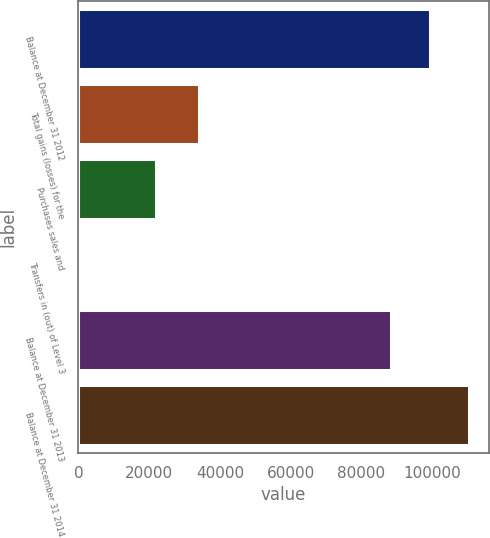<chart> <loc_0><loc_0><loc_500><loc_500><bar_chart><fcel>Balance at December 31 2012<fcel>Total gains (losses) for the<fcel>Purchases sales and<fcel>Transfers in (out) of Level 3<fcel>Balance at December 31 2013<fcel>Balance at December 31 2014<nl><fcel>99475.1<fcel>34071<fcel>21987.8<fcel>1.49<fcel>88482<fcel>110468<nl></chart> 